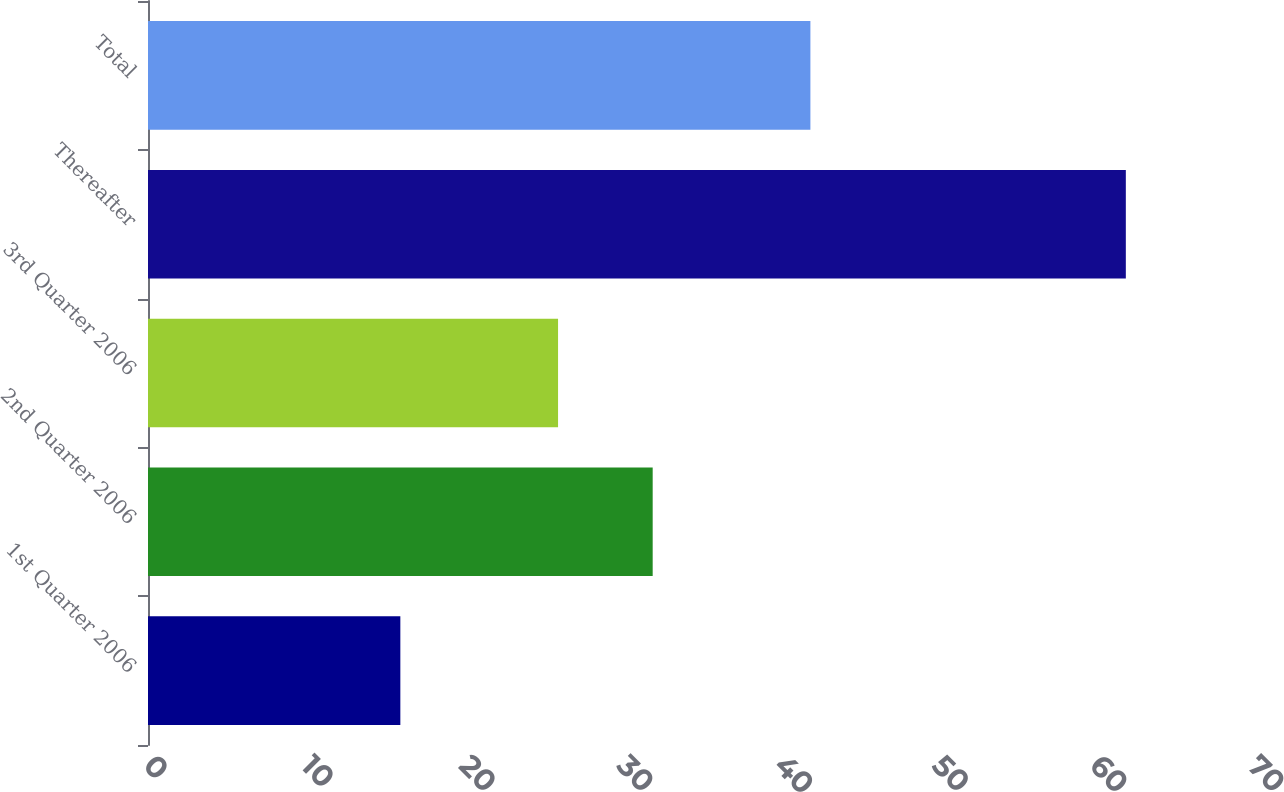Convert chart. <chart><loc_0><loc_0><loc_500><loc_500><bar_chart><fcel>1st Quarter 2006<fcel>2nd Quarter 2006<fcel>3rd Quarter 2006<fcel>Thereafter<fcel>Total<nl><fcel>16<fcel>32<fcel>26<fcel>62<fcel>42<nl></chart> 